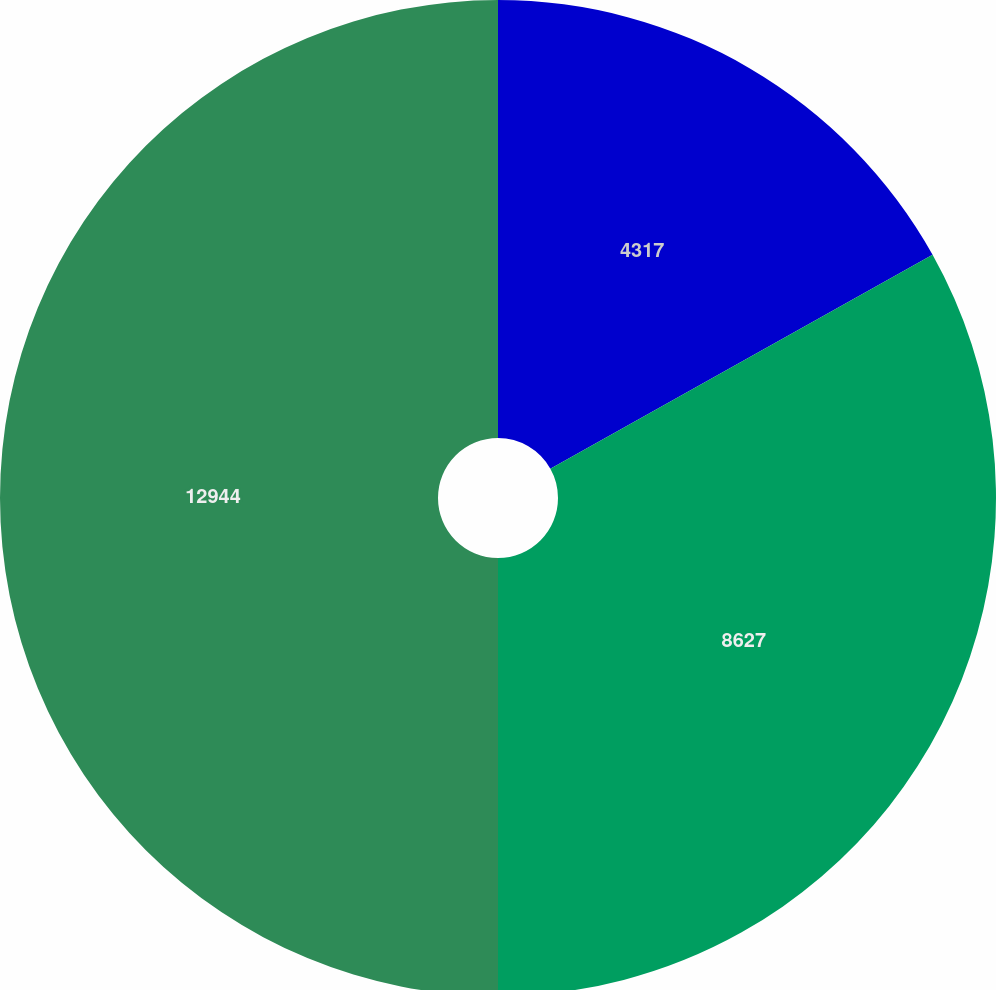Convert chart. <chart><loc_0><loc_0><loc_500><loc_500><pie_chart><fcel>4317<fcel>8627<fcel>12944<nl><fcel>16.88%<fcel>33.12%<fcel>50.0%<nl></chart> 